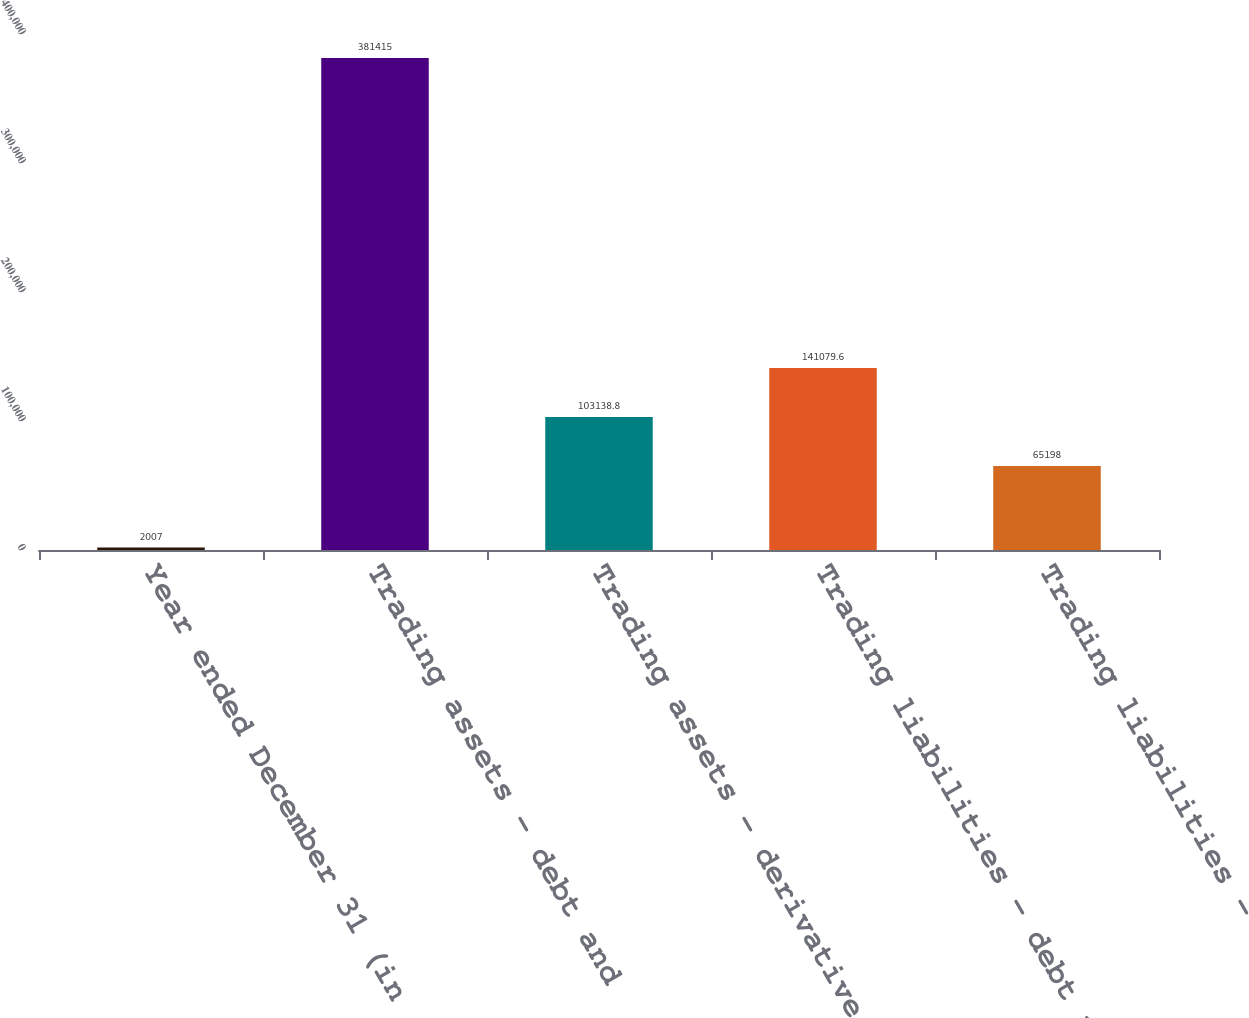Convert chart to OTSL. <chart><loc_0><loc_0><loc_500><loc_500><bar_chart><fcel>Year ended December 31 (in<fcel>Trading assets - debt and<fcel>Trading assets - derivative<fcel>Trading liabilities - debt and<fcel>Trading liabilities -<nl><fcel>2007<fcel>381415<fcel>103139<fcel>141080<fcel>65198<nl></chart> 